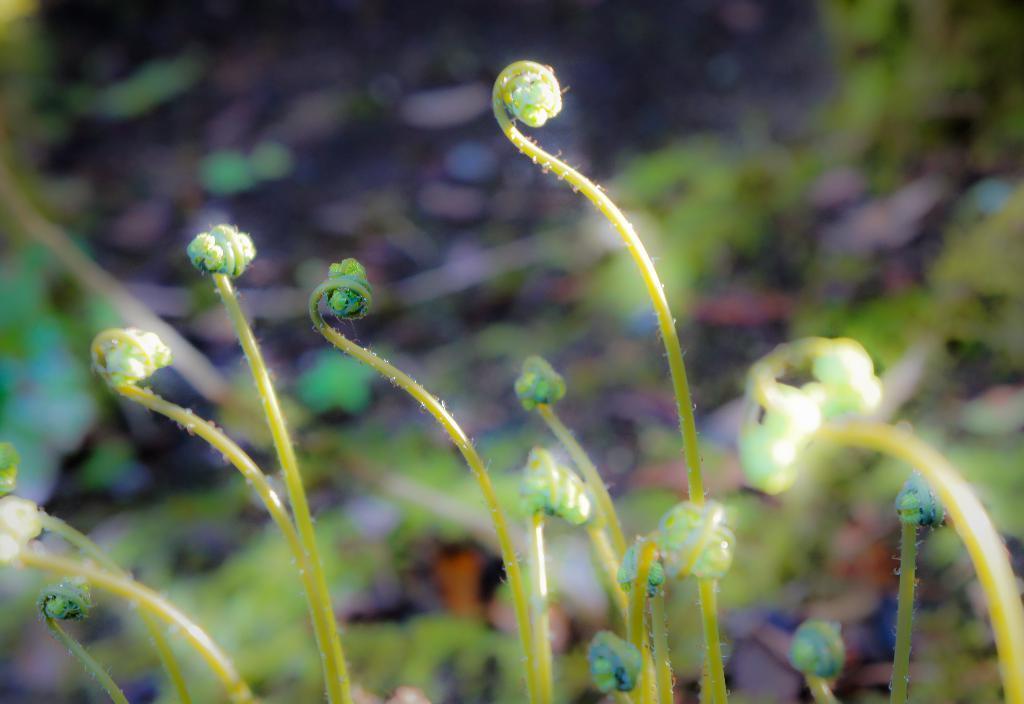How would you summarize this image in a sentence or two? In the image we can see the plants and the background is blurred. 